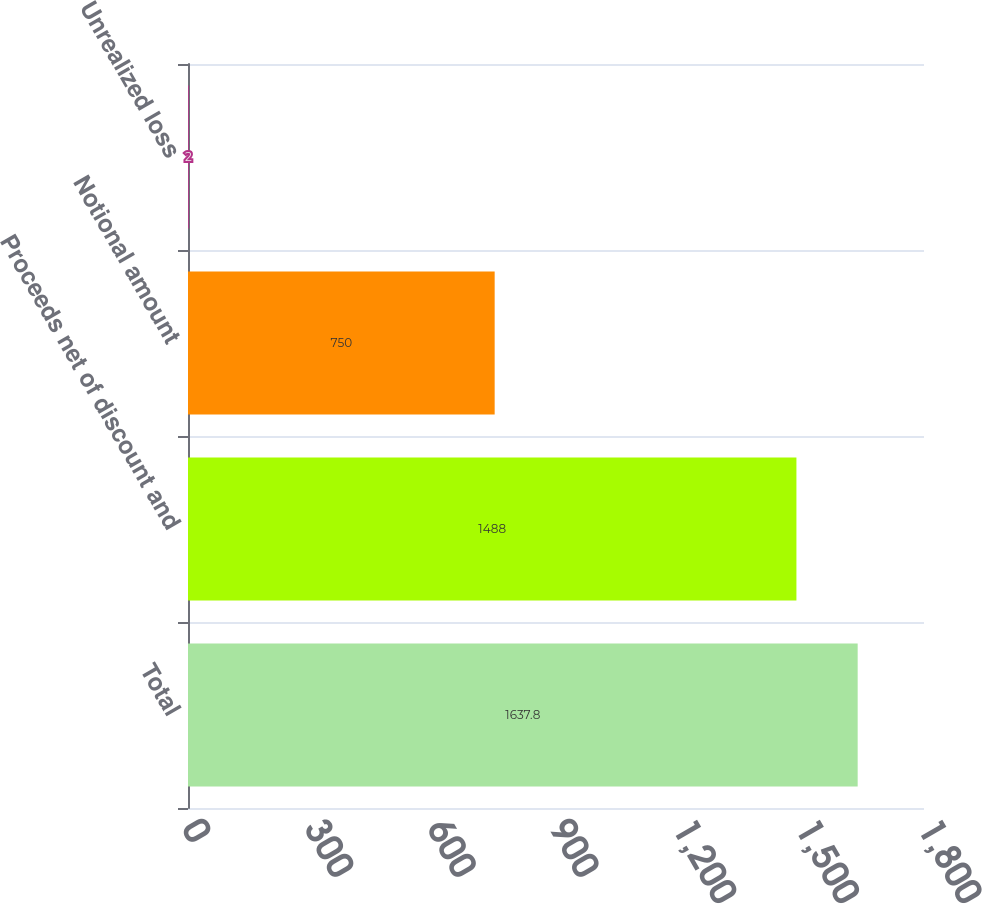Convert chart to OTSL. <chart><loc_0><loc_0><loc_500><loc_500><bar_chart><fcel>Total<fcel>Proceeds net of discount and<fcel>Notional amount<fcel>Unrealized loss<nl><fcel>1637.8<fcel>1488<fcel>750<fcel>2<nl></chart> 